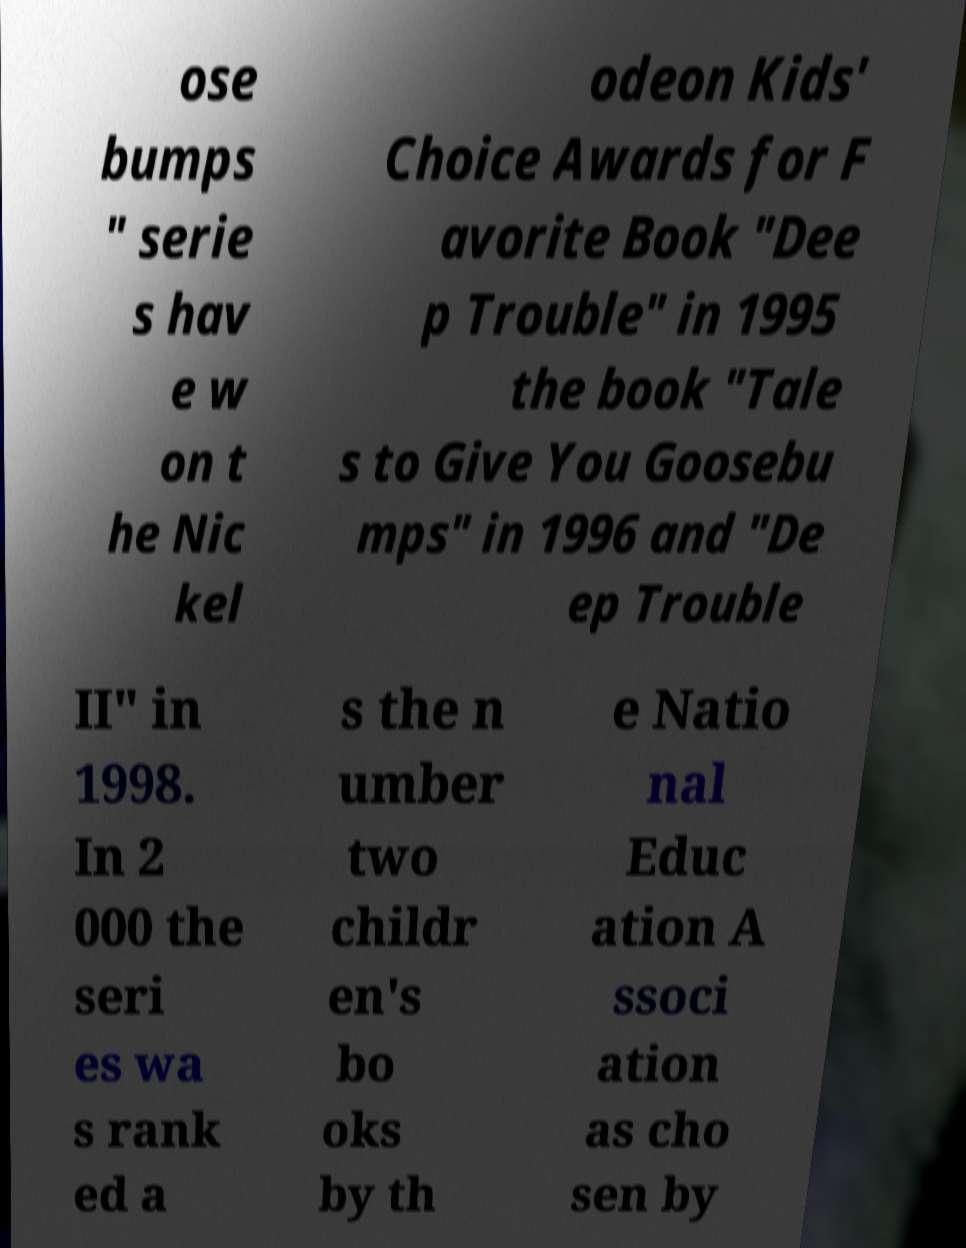Could you assist in decoding the text presented in this image and type it out clearly? ose bumps " serie s hav e w on t he Nic kel odeon Kids' Choice Awards for F avorite Book "Dee p Trouble" in 1995 the book "Tale s to Give You Goosebu mps" in 1996 and "De ep Trouble II" in 1998. In 2 000 the seri es wa s rank ed a s the n umber two childr en's bo oks by th e Natio nal Educ ation A ssoci ation as cho sen by 